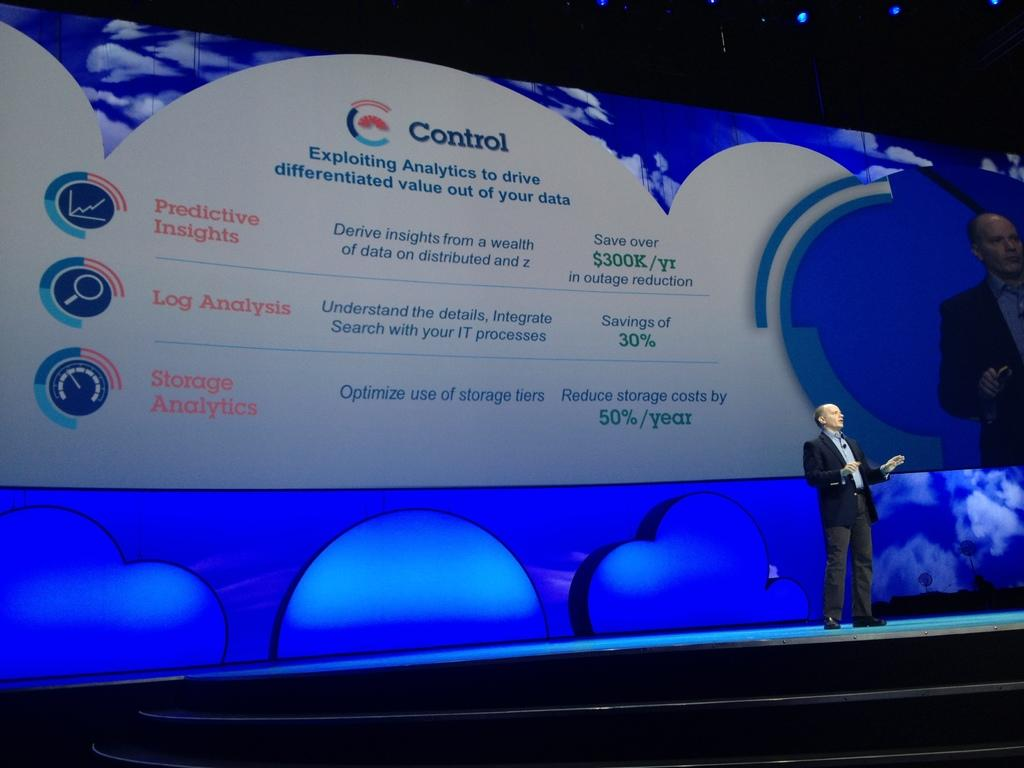<image>
Present a compact description of the photo's key features. A man giving a presentation on a stage with a slide behind him that says Control. 